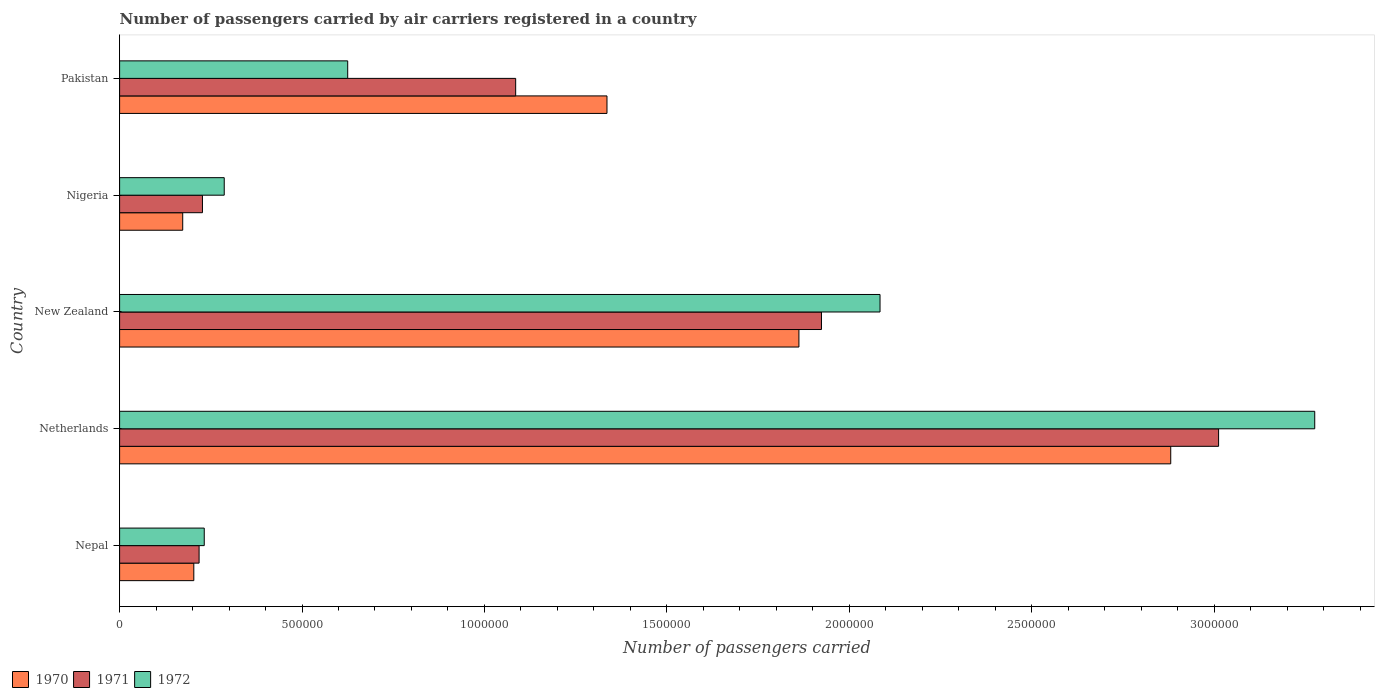How many bars are there on the 1st tick from the top?
Your answer should be compact. 3. How many bars are there on the 1st tick from the bottom?
Your response must be concise. 3. What is the label of the 3rd group of bars from the top?
Your answer should be compact. New Zealand. In how many cases, is the number of bars for a given country not equal to the number of legend labels?
Your response must be concise. 0. What is the number of passengers carried by air carriers in 1972 in Pakistan?
Give a very brief answer. 6.25e+05. Across all countries, what is the maximum number of passengers carried by air carriers in 1972?
Your answer should be very brief. 3.28e+06. Across all countries, what is the minimum number of passengers carried by air carriers in 1972?
Provide a succinct answer. 2.32e+05. In which country was the number of passengers carried by air carriers in 1971 maximum?
Your answer should be very brief. Netherlands. In which country was the number of passengers carried by air carriers in 1971 minimum?
Keep it short and to the point. Nepal. What is the total number of passengers carried by air carriers in 1971 in the graph?
Your answer should be very brief. 6.47e+06. What is the difference between the number of passengers carried by air carriers in 1970 in New Zealand and that in Pakistan?
Make the answer very short. 5.26e+05. What is the difference between the number of passengers carried by air carriers in 1970 in Netherlands and the number of passengers carried by air carriers in 1972 in Nepal?
Your answer should be very brief. 2.65e+06. What is the average number of passengers carried by air carriers in 1970 per country?
Offer a terse response. 1.29e+06. What is the difference between the number of passengers carried by air carriers in 1971 and number of passengers carried by air carriers in 1970 in Netherlands?
Provide a short and direct response. 1.31e+05. In how many countries, is the number of passengers carried by air carriers in 1972 greater than 1500000 ?
Provide a succinct answer. 2. What is the ratio of the number of passengers carried by air carriers in 1972 in Netherlands to that in New Zealand?
Provide a succinct answer. 1.57. What is the difference between the highest and the second highest number of passengers carried by air carriers in 1971?
Provide a succinct answer. 1.09e+06. What is the difference between the highest and the lowest number of passengers carried by air carriers in 1972?
Ensure brevity in your answer.  3.04e+06. What does the 3rd bar from the top in Netherlands represents?
Keep it short and to the point. 1970. How many countries are there in the graph?
Give a very brief answer. 5. What is the difference between two consecutive major ticks on the X-axis?
Ensure brevity in your answer.  5.00e+05. Are the values on the major ticks of X-axis written in scientific E-notation?
Make the answer very short. No. Does the graph contain grids?
Provide a short and direct response. No. How many legend labels are there?
Offer a terse response. 3. How are the legend labels stacked?
Offer a terse response. Horizontal. What is the title of the graph?
Provide a short and direct response. Number of passengers carried by air carriers registered in a country. Does "1973" appear as one of the legend labels in the graph?
Offer a very short reply. No. What is the label or title of the X-axis?
Your response must be concise. Number of passengers carried. What is the label or title of the Y-axis?
Offer a very short reply. Country. What is the Number of passengers carried in 1970 in Nepal?
Offer a very short reply. 2.03e+05. What is the Number of passengers carried of 1971 in Nepal?
Offer a terse response. 2.18e+05. What is the Number of passengers carried of 1972 in Nepal?
Keep it short and to the point. 2.32e+05. What is the Number of passengers carried in 1970 in Netherlands?
Your answer should be compact. 2.88e+06. What is the Number of passengers carried in 1971 in Netherlands?
Your response must be concise. 3.01e+06. What is the Number of passengers carried of 1972 in Netherlands?
Your response must be concise. 3.28e+06. What is the Number of passengers carried in 1970 in New Zealand?
Your answer should be very brief. 1.86e+06. What is the Number of passengers carried of 1971 in New Zealand?
Give a very brief answer. 1.92e+06. What is the Number of passengers carried of 1972 in New Zealand?
Keep it short and to the point. 2.08e+06. What is the Number of passengers carried of 1970 in Nigeria?
Ensure brevity in your answer.  1.73e+05. What is the Number of passengers carried of 1971 in Nigeria?
Your answer should be compact. 2.27e+05. What is the Number of passengers carried in 1972 in Nigeria?
Ensure brevity in your answer.  2.87e+05. What is the Number of passengers carried in 1970 in Pakistan?
Your response must be concise. 1.34e+06. What is the Number of passengers carried in 1971 in Pakistan?
Keep it short and to the point. 1.09e+06. What is the Number of passengers carried of 1972 in Pakistan?
Offer a very short reply. 6.25e+05. Across all countries, what is the maximum Number of passengers carried of 1970?
Keep it short and to the point. 2.88e+06. Across all countries, what is the maximum Number of passengers carried of 1971?
Your response must be concise. 3.01e+06. Across all countries, what is the maximum Number of passengers carried of 1972?
Offer a terse response. 3.28e+06. Across all countries, what is the minimum Number of passengers carried in 1970?
Your response must be concise. 1.73e+05. Across all countries, what is the minimum Number of passengers carried in 1971?
Provide a short and direct response. 2.18e+05. Across all countries, what is the minimum Number of passengers carried in 1972?
Provide a short and direct response. 2.32e+05. What is the total Number of passengers carried of 1970 in the graph?
Ensure brevity in your answer.  6.46e+06. What is the total Number of passengers carried in 1971 in the graph?
Keep it short and to the point. 6.47e+06. What is the total Number of passengers carried of 1972 in the graph?
Provide a succinct answer. 6.50e+06. What is the difference between the Number of passengers carried of 1970 in Nepal and that in Netherlands?
Your answer should be very brief. -2.68e+06. What is the difference between the Number of passengers carried of 1971 in Nepal and that in Netherlands?
Keep it short and to the point. -2.79e+06. What is the difference between the Number of passengers carried of 1972 in Nepal and that in Netherlands?
Make the answer very short. -3.04e+06. What is the difference between the Number of passengers carried of 1970 in Nepal and that in New Zealand?
Provide a short and direct response. -1.66e+06. What is the difference between the Number of passengers carried in 1971 in Nepal and that in New Zealand?
Keep it short and to the point. -1.71e+06. What is the difference between the Number of passengers carried in 1972 in Nepal and that in New Zealand?
Your answer should be very brief. -1.85e+06. What is the difference between the Number of passengers carried in 1970 in Nepal and that in Nigeria?
Your answer should be compact. 3.04e+04. What is the difference between the Number of passengers carried in 1971 in Nepal and that in Nigeria?
Ensure brevity in your answer.  -9200. What is the difference between the Number of passengers carried of 1972 in Nepal and that in Nigeria?
Your answer should be compact. -5.48e+04. What is the difference between the Number of passengers carried in 1970 in Nepal and that in Pakistan?
Offer a very short reply. -1.13e+06. What is the difference between the Number of passengers carried in 1971 in Nepal and that in Pakistan?
Offer a terse response. -8.68e+05. What is the difference between the Number of passengers carried of 1972 in Nepal and that in Pakistan?
Your answer should be compact. -3.93e+05. What is the difference between the Number of passengers carried in 1970 in Netherlands and that in New Zealand?
Provide a short and direct response. 1.02e+06. What is the difference between the Number of passengers carried in 1971 in Netherlands and that in New Zealand?
Ensure brevity in your answer.  1.09e+06. What is the difference between the Number of passengers carried of 1972 in Netherlands and that in New Zealand?
Offer a very short reply. 1.19e+06. What is the difference between the Number of passengers carried of 1970 in Netherlands and that in Nigeria?
Ensure brevity in your answer.  2.71e+06. What is the difference between the Number of passengers carried in 1971 in Netherlands and that in Nigeria?
Provide a succinct answer. 2.79e+06. What is the difference between the Number of passengers carried of 1972 in Netherlands and that in Nigeria?
Provide a succinct answer. 2.99e+06. What is the difference between the Number of passengers carried of 1970 in Netherlands and that in Pakistan?
Offer a terse response. 1.55e+06. What is the difference between the Number of passengers carried of 1971 in Netherlands and that in Pakistan?
Offer a terse response. 1.93e+06. What is the difference between the Number of passengers carried in 1972 in Netherlands and that in Pakistan?
Make the answer very short. 2.65e+06. What is the difference between the Number of passengers carried of 1970 in New Zealand and that in Nigeria?
Your response must be concise. 1.69e+06. What is the difference between the Number of passengers carried of 1971 in New Zealand and that in Nigeria?
Provide a succinct answer. 1.70e+06. What is the difference between the Number of passengers carried in 1972 in New Zealand and that in Nigeria?
Offer a terse response. 1.80e+06. What is the difference between the Number of passengers carried of 1970 in New Zealand and that in Pakistan?
Make the answer very short. 5.26e+05. What is the difference between the Number of passengers carried in 1971 in New Zealand and that in Pakistan?
Give a very brief answer. 8.38e+05. What is the difference between the Number of passengers carried in 1972 in New Zealand and that in Pakistan?
Your answer should be compact. 1.46e+06. What is the difference between the Number of passengers carried in 1970 in Nigeria and that in Pakistan?
Provide a succinct answer. -1.16e+06. What is the difference between the Number of passengers carried in 1971 in Nigeria and that in Pakistan?
Offer a terse response. -8.58e+05. What is the difference between the Number of passengers carried in 1972 in Nigeria and that in Pakistan?
Your answer should be compact. -3.38e+05. What is the difference between the Number of passengers carried of 1970 in Nepal and the Number of passengers carried of 1971 in Netherlands?
Give a very brief answer. -2.81e+06. What is the difference between the Number of passengers carried of 1970 in Nepal and the Number of passengers carried of 1972 in Netherlands?
Offer a very short reply. -3.07e+06. What is the difference between the Number of passengers carried of 1971 in Nepal and the Number of passengers carried of 1972 in Netherlands?
Your answer should be compact. -3.06e+06. What is the difference between the Number of passengers carried in 1970 in Nepal and the Number of passengers carried in 1971 in New Zealand?
Your answer should be very brief. -1.72e+06. What is the difference between the Number of passengers carried in 1970 in Nepal and the Number of passengers carried in 1972 in New Zealand?
Your response must be concise. -1.88e+06. What is the difference between the Number of passengers carried in 1971 in Nepal and the Number of passengers carried in 1972 in New Zealand?
Your answer should be very brief. -1.87e+06. What is the difference between the Number of passengers carried in 1970 in Nepal and the Number of passengers carried in 1971 in Nigeria?
Provide a short and direct response. -2.37e+04. What is the difference between the Number of passengers carried in 1970 in Nepal and the Number of passengers carried in 1972 in Nigeria?
Your response must be concise. -8.34e+04. What is the difference between the Number of passengers carried of 1971 in Nepal and the Number of passengers carried of 1972 in Nigeria?
Offer a very short reply. -6.89e+04. What is the difference between the Number of passengers carried in 1970 in Nepal and the Number of passengers carried in 1971 in Pakistan?
Keep it short and to the point. -8.82e+05. What is the difference between the Number of passengers carried of 1970 in Nepal and the Number of passengers carried of 1972 in Pakistan?
Give a very brief answer. -4.22e+05. What is the difference between the Number of passengers carried of 1971 in Nepal and the Number of passengers carried of 1972 in Pakistan?
Your answer should be very brief. -4.07e+05. What is the difference between the Number of passengers carried of 1970 in Netherlands and the Number of passengers carried of 1971 in New Zealand?
Provide a succinct answer. 9.57e+05. What is the difference between the Number of passengers carried of 1970 in Netherlands and the Number of passengers carried of 1972 in New Zealand?
Make the answer very short. 7.97e+05. What is the difference between the Number of passengers carried of 1971 in Netherlands and the Number of passengers carried of 1972 in New Zealand?
Your answer should be very brief. 9.28e+05. What is the difference between the Number of passengers carried in 1970 in Netherlands and the Number of passengers carried in 1971 in Nigeria?
Your answer should be very brief. 2.65e+06. What is the difference between the Number of passengers carried of 1970 in Netherlands and the Number of passengers carried of 1972 in Nigeria?
Keep it short and to the point. 2.59e+06. What is the difference between the Number of passengers carried in 1971 in Netherlands and the Number of passengers carried in 1972 in Nigeria?
Make the answer very short. 2.73e+06. What is the difference between the Number of passengers carried of 1970 in Netherlands and the Number of passengers carried of 1971 in Pakistan?
Offer a very short reply. 1.80e+06. What is the difference between the Number of passengers carried of 1970 in Netherlands and the Number of passengers carried of 1972 in Pakistan?
Provide a short and direct response. 2.26e+06. What is the difference between the Number of passengers carried of 1971 in Netherlands and the Number of passengers carried of 1972 in Pakistan?
Give a very brief answer. 2.39e+06. What is the difference between the Number of passengers carried in 1970 in New Zealand and the Number of passengers carried in 1971 in Nigeria?
Your answer should be compact. 1.63e+06. What is the difference between the Number of passengers carried of 1970 in New Zealand and the Number of passengers carried of 1972 in Nigeria?
Your response must be concise. 1.58e+06. What is the difference between the Number of passengers carried of 1971 in New Zealand and the Number of passengers carried of 1972 in Nigeria?
Make the answer very short. 1.64e+06. What is the difference between the Number of passengers carried in 1970 in New Zealand and the Number of passengers carried in 1971 in Pakistan?
Provide a short and direct response. 7.76e+05. What is the difference between the Number of passengers carried of 1970 in New Zealand and the Number of passengers carried of 1972 in Pakistan?
Keep it short and to the point. 1.24e+06. What is the difference between the Number of passengers carried in 1971 in New Zealand and the Number of passengers carried in 1972 in Pakistan?
Offer a terse response. 1.30e+06. What is the difference between the Number of passengers carried of 1970 in Nigeria and the Number of passengers carried of 1971 in Pakistan?
Provide a succinct answer. -9.13e+05. What is the difference between the Number of passengers carried in 1970 in Nigeria and the Number of passengers carried in 1972 in Pakistan?
Give a very brief answer. -4.52e+05. What is the difference between the Number of passengers carried in 1971 in Nigeria and the Number of passengers carried in 1972 in Pakistan?
Your answer should be very brief. -3.98e+05. What is the average Number of passengers carried of 1970 per country?
Make the answer very short. 1.29e+06. What is the average Number of passengers carried in 1971 per country?
Give a very brief answer. 1.29e+06. What is the average Number of passengers carried of 1972 per country?
Give a very brief answer. 1.30e+06. What is the difference between the Number of passengers carried in 1970 and Number of passengers carried in 1971 in Nepal?
Your response must be concise. -1.45e+04. What is the difference between the Number of passengers carried in 1970 and Number of passengers carried in 1972 in Nepal?
Give a very brief answer. -2.86e+04. What is the difference between the Number of passengers carried of 1971 and Number of passengers carried of 1972 in Nepal?
Offer a terse response. -1.41e+04. What is the difference between the Number of passengers carried of 1970 and Number of passengers carried of 1971 in Netherlands?
Ensure brevity in your answer.  -1.31e+05. What is the difference between the Number of passengers carried in 1970 and Number of passengers carried in 1972 in Netherlands?
Provide a succinct answer. -3.95e+05. What is the difference between the Number of passengers carried of 1971 and Number of passengers carried of 1972 in Netherlands?
Offer a very short reply. -2.64e+05. What is the difference between the Number of passengers carried of 1970 and Number of passengers carried of 1971 in New Zealand?
Ensure brevity in your answer.  -6.18e+04. What is the difference between the Number of passengers carried in 1970 and Number of passengers carried in 1972 in New Zealand?
Your response must be concise. -2.22e+05. What is the difference between the Number of passengers carried of 1971 and Number of passengers carried of 1972 in New Zealand?
Ensure brevity in your answer.  -1.60e+05. What is the difference between the Number of passengers carried of 1970 and Number of passengers carried of 1971 in Nigeria?
Offer a very short reply. -5.41e+04. What is the difference between the Number of passengers carried of 1970 and Number of passengers carried of 1972 in Nigeria?
Offer a very short reply. -1.14e+05. What is the difference between the Number of passengers carried in 1971 and Number of passengers carried in 1972 in Nigeria?
Give a very brief answer. -5.97e+04. What is the difference between the Number of passengers carried in 1970 and Number of passengers carried in 1971 in Pakistan?
Your answer should be compact. 2.50e+05. What is the difference between the Number of passengers carried in 1970 and Number of passengers carried in 1972 in Pakistan?
Offer a terse response. 7.11e+05. What is the difference between the Number of passengers carried in 1971 and Number of passengers carried in 1972 in Pakistan?
Provide a short and direct response. 4.60e+05. What is the ratio of the Number of passengers carried in 1970 in Nepal to that in Netherlands?
Make the answer very short. 0.07. What is the ratio of the Number of passengers carried in 1971 in Nepal to that in Netherlands?
Give a very brief answer. 0.07. What is the ratio of the Number of passengers carried of 1972 in Nepal to that in Netherlands?
Offer a very short reply. 0.07. What is the ratio of the Number of passengers carried of 1970 in Nepal to that in New Zealand?
Keep it short and to the point. 0.11. What is the ratio of the Number of passengers carried in 1971 in Nepal to that in New Zealand?
Offer a terse response. 0.11. What is the ratio of the Number of passengers carried in 1972 in Nepal to that in New Zealand?
Provide a succinct answer. 0.11. What is the ratio of the Number of passengers carried in 1970 in Nepal to that in Nigeria?
Keep it short and to the point. 1.18. What is the ratio of the Number of passengers carried in 1971 in Nepal to that in Nigeria?
Your response must be concise. 0.96. What is the ratio of the Number of passengers carried in 1972 in Nepal to that in Nigeria?
Your answer should be very brief. 0.81. What is the ratio of the Number of passengers carried in 1970 in Nepal to that in Pakistan?
Your answer should be very brief. 0.15. What is the ratio of the Number of passengers carried in 1971 in Nepal to that in Pakistan?
Provide a succinct answer. 0.2. What is the ratio of the Number of passengers carried in 1972 in Nepal to that in Pakistan?
Your answer should be compact. 0.37. What is the ratio of the Number of passengers carried in 1970 in Netherlands to that in New Zealand?
Offer a very short reply. 1.55. What is the ratio of the Number of passengers carried of 1971 in Netherlands to that in New Zealand?
Provide a succinct answer. 1.57. What is the ratio of the Number of passengers carried of 1972 in Netherlands to that in New Zealand?
Give a very brief answer. 1.57. What is the ratio of the Number of passengers carried of 1970 in Netherlands to that in Nigeria?
Your answer should be very brief. 16.65. What is the ratio of the Number of passengers carried of 1971 in Netherlands to that in Nigeria?
Your answer should be very brief. 13.26. What is the ratio of the Number of passengers carried in 1972 in Netherlands to that in Nigeria?
Keep it short and to the point. 11.42. What is the ratio of the Number of passengers carried of 1970 in Netherlands to that in Pakistan?
Your response must be concise. 2.16. What is the ratio of the Number of passengers carried of 1971 in Netherlands to that in Pakistan?
Your response must be concise. 2.77. What is the ratio of the Number of passengers carried of 1972 in Netherlands to that in Pakistan?
Keep it short and to the point. 5.24. What is the ratio of the Number of passengers carried in 1970 in New Zealand to that in Nigeria?
Make the answer very short. 10.76. What is the ratio of the Number of passengers carried in 1971 in New Zealand to that in Nigeria?
Keep it short and to the point. 8.47. What is the ratio of the Number of passengers carried of 1972 in New Zealand to that in Nigeria?
Your response must be concise. 7.27. What is the ratio of the Number of passengers carried of 1970 in New Zealand to that in Pakistan?
Your response must be concise. 1.39. What is the ratio of the Number of passengers carried of 1971 in New Zealand to that in Pakistan?
Your response must be concise. 1.77. What is the ratio of the Number of passengers carried of 1972 in New Zealand to that in Pakistan?
Ensure brevity in your answer.  3.33. What is the ratio of the Number of passengers carried in 1970 in Nigeria to that in Pakistan?
Your answer should be compact. 0.13. What is the ratio of the Number of passengers carried in 1971 in Nigeria to that in Pakistan?
Ensure brevity in your answer.  0.21. What is the ratio of the Number of passengers carried of 1972 in Nigeria to that in Pakistan?
Provide a succinct answer. 0.46. What is the difference between the highest and the second highest Number of passengers carried in 1970?
Your answer should be very brief. 1.02e+06. What is the difference between the highest and the second highest Number of passengers carried in 1971?
Your response must be concise. 1.09e+06. What is the difference between the highest and the second highest Number of passengers carried of 1972?
Provide a short and direct response. 1.19e+06. What is the difference between the highest and the lowest Number of passengers carried in 1970?
Ensure brevity in your answer.  2.71e+06. What is the difference between the highest and the lowest Number of passengers carried in 1971?
Your answer should be very brief. 2.79e+06. What is the difference between the highest and the lowest Number of passengers carried of 1972?
Your response must be concise. 3.04e+06. 